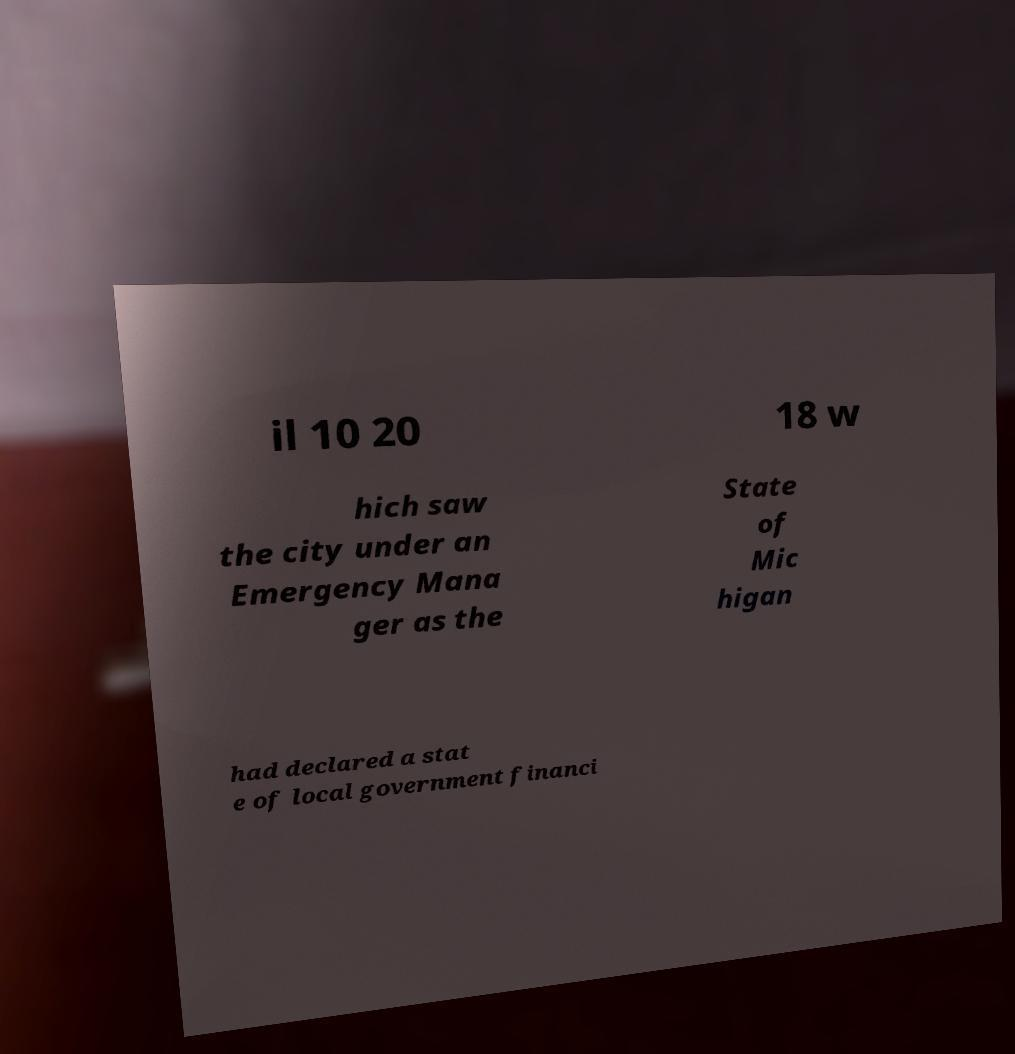Please identify and transcribe the text found in this image. il 10 20 18 w hich saw the city under an Emergency Mana ger as the State of Mic higan had declared a stat e of local government financi 